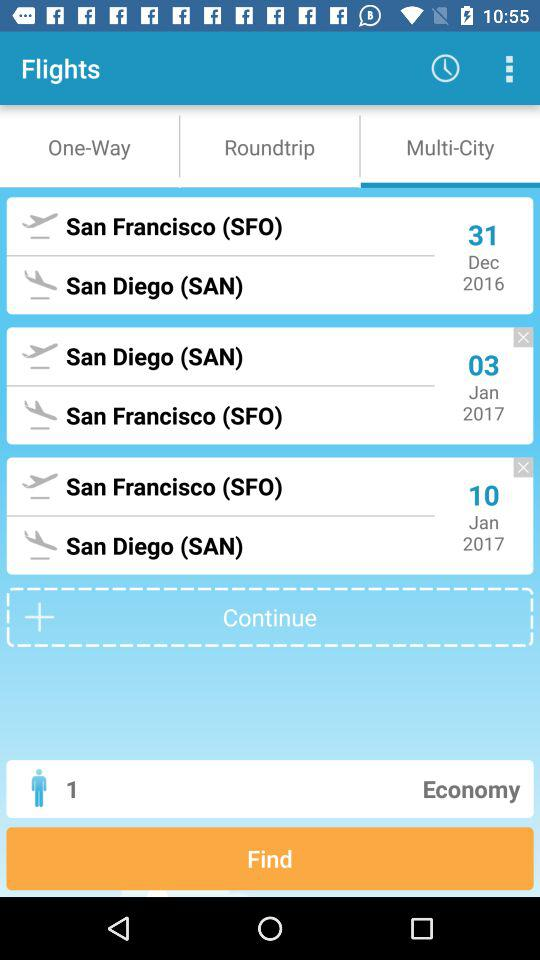What's the number of passengers? The number of passengers is 1. 